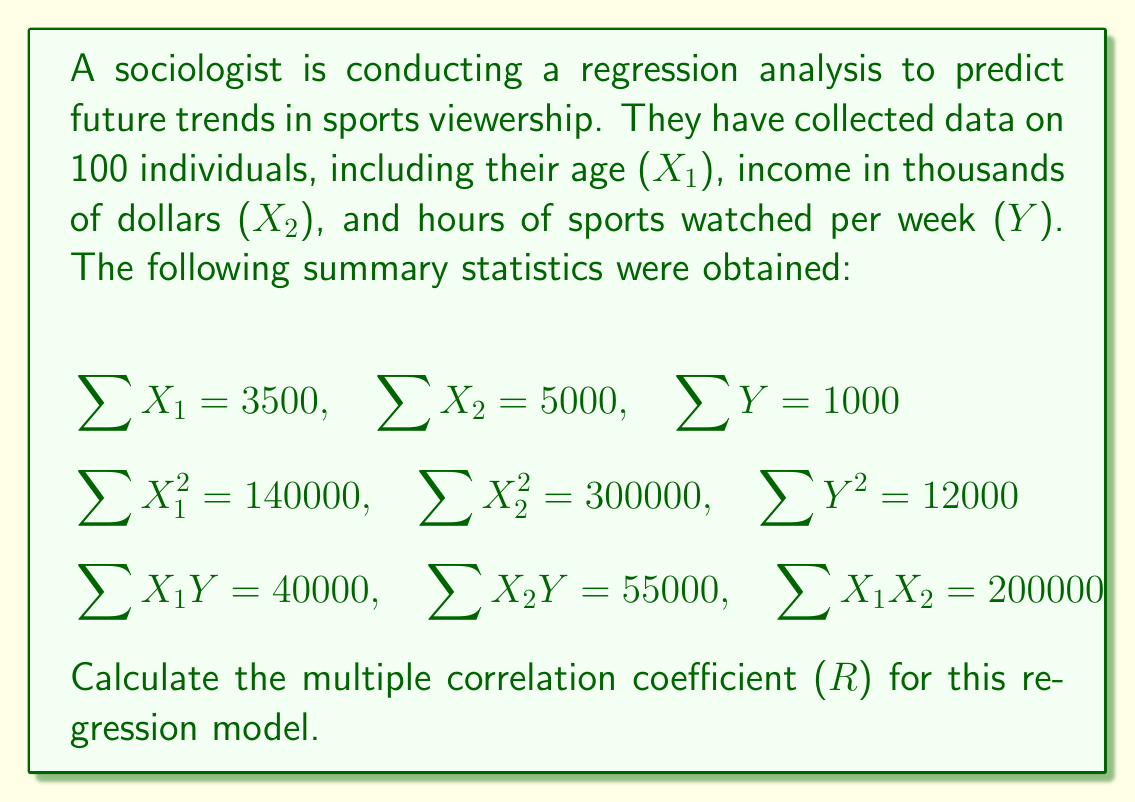Give your solution to this math problem. To calculate the multiple correlation coefficient (R), we need to follow these steps:

1. Calculate the means:
   $\bar{X_1} = \frac{\sum X_1}{n} = \frac{3500}{100} = 35$
   $\bar{X_2} = \frac{\sum X_2}{n} = \frac{5000}{100} = 50$
   $\bar{Y} = \frac{\sum Y}{n} = \frac{1000}{100} = 10$

2. Calculate the sums of squares:
   $SS_{X_1} = \sum X_1^2 - \frac{(\sum X_1)^2}{n} = 140000 - \frac{3500^2}{100} = 17500$
   $SS_{X_2} = \sum X_2^2 - \frac{(\sum X_2)^2}{n} = 300000 - \frac{5000^2}{100} = 50000$
   $SS_Y = \sum Y^2 - \frac{(\sum Y)^2}{n} = 12000 - \frac{1000^2}{100} = 2000$

3. Calculate the sums of products:
   $SP_{X_1Y} = \sum X_1Y - \frac{\sum X_1 \sum Y}{n} = 40000 - \frac{3500 \cdot 1000}{100} = 5000$
   $SP_{X_2Y} = \sum X_2Y - \frac{\sum X_2 \sum Y}{n} = 55000 - \frac{5000 \cdot 1000}{100} = 5000$
   $SP_{X_1X_2} = \sum X_1X_2 - \frac{\sum X_1 \sum X_2}{n} = 200000 - \frac{3500 \cdot 5000}{100} = 25000$

4. Calculate the regression coefficients:
   $b_1 = \frac{SS_{X_2} \cdot SP_{X_1Y} - SP_{X_1X_2} \cdot SP_{X_2Y}}{SS_{X_1} \cdot SS_{X_2} - SP_{X_1X_2}^2}$
   $b_1 = \frac{50000 \cdot 5000 - 25000 \cdot 5000}{17500 \cdot 50000 - 25000^2} = 0.2$

   $b_2 = \frac{SS_{X_1} \cdot SP_{X_2Y} - SP_{X_1X_2} \cdot SP_{X_1Y}}{SS_{X_1} \cdot SS_{X_2} - SP_{X_1X_2}^2}$
   $b_2 = \frac{17500 \cdot 5000 - 25000 \cdot 5000}{17500 \cdot 50000 - 25000^2} = 0.04$

5. Calculate the coefficient of determination (R²):
   $R^2 = \frac{b_1 \cdot SP_{X_1Y} + b_2 \cdot SP_{X_2Y}}{SS_Y}$
   $R^2 = \frac{0.2 \cdot 5000 + 0.04 \cdot 5000}{2000} = 0.6$

6. Calculate the multiple correlation coefficient (R):
   $R = \sqrt{R^2} = \sqrt{0.6} = 0.7746$
Answer: $R = 0.7746$ 